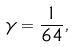<formula> <loc_0><loc_0><loc_500><loc_500>\gamma = \frac { 1 } { 6 4 } ,</formula> 